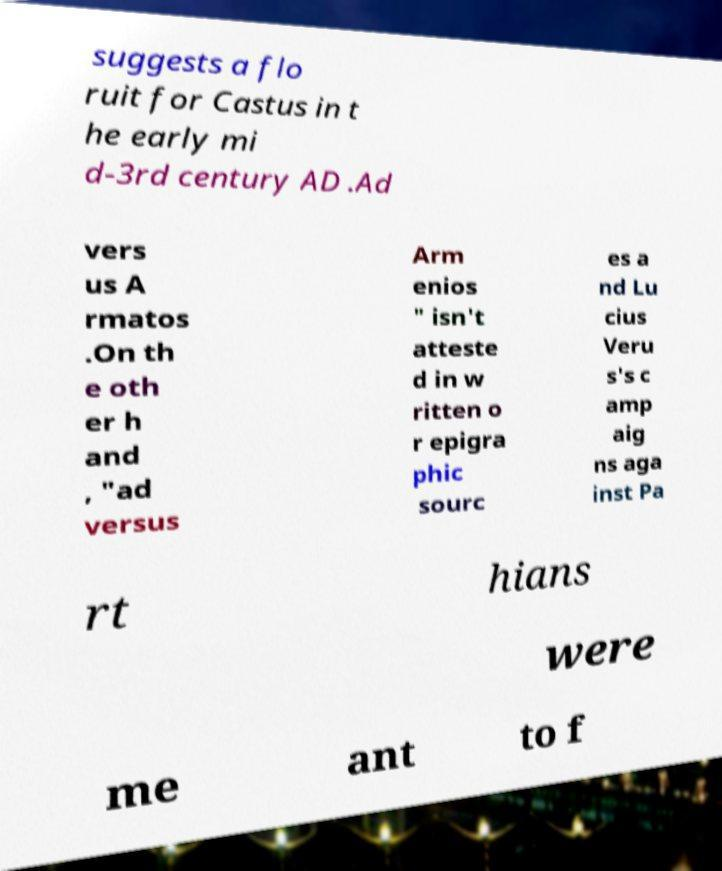For documentation purposes, I need the text within this image transcribed. Could you provide that? suggests a flo ruit for Castus in t he early mi d-3rd century AD .Ad vers us A rmatos .On th e oth er h and , "ad versus Arm enios " isn't atteste d in w ritten o r epigra phic sourc es a nd Lu cius Veru s's c amp aig ns aga inst Pa rt hians were me ant to f 